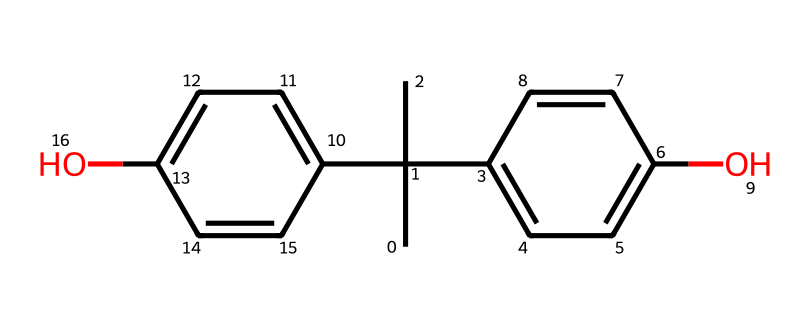What is the molecular formula of bisphenol A? The molecular formula can be deduced by counting the number of carbon (C), hydrogen (H), and oxygen (O) atoms in the structure. There are 15 carbon atoms, 16 hydrogen atoms, and 2 oxygen atoms, resulting in the formula C15H16O2.
Answer: C15H16O2 How many hydroxyl groups are present in bisphenol A? By identifying the functional groups in the structure, we can see that there are two -OH (hydroxyl) groups attached to the aromatic rings, which classify it as a bisphenol.
Answer: 2 Is bisphenol A symmetrical? The two aromatic rings in bisphenol A exhibit symmetry along the central carbon, as they are identical in structure and bonding to the hydroxyl groups, leading to overall symmetry in the molecule.
Answer: Yes What type of reactions can bisphenol A undergo due to its hydroxyl groups? The presence of hydroxyl groups in bisphenol A allows it to participate in hydrogen bonding and can also undergo substitution reactions typical for phenols, such as electrophilic aromatic substitution. This characteristic is an important feature of phenolic compounds.
Answer: Electrophilic aromatic substitution What is the significance of the methyl groups in the bisphenol A structure? The methyl groups (specifically the tertiary carbon arrangement) provide steric hindrance that decreases the reactivity of the molecule compared to other phenols. They also contribute to the hydrophobic nature of bisphenol A, modifying its solubility and biological interactions.
Answer: Steric hindrance How many double bonds are present in bisphenol A? The structure shows that there are four carbon-carbon double bonds (C=C) within the two aromatic rings, which is characteristic of phenolic compounds and contributes to their stability and reactivity.
Answer: 4 